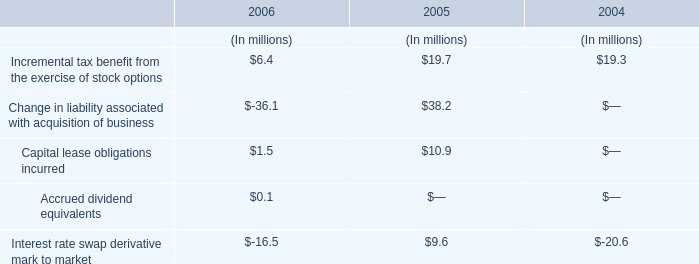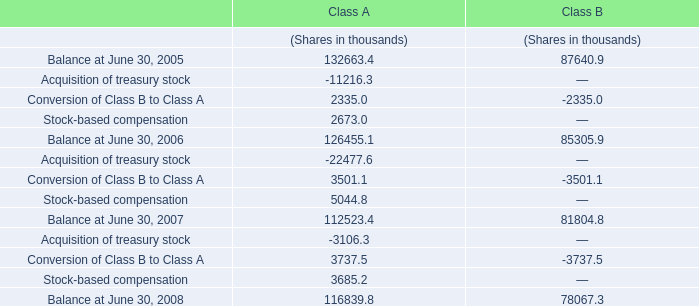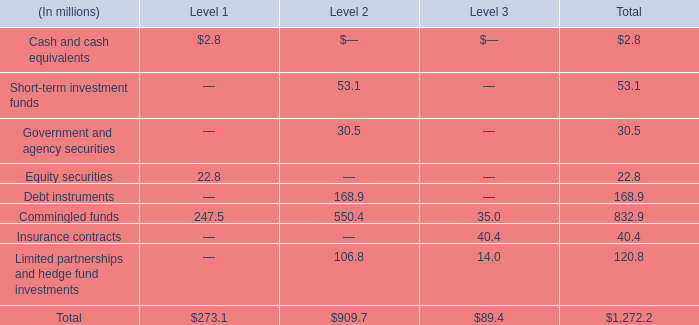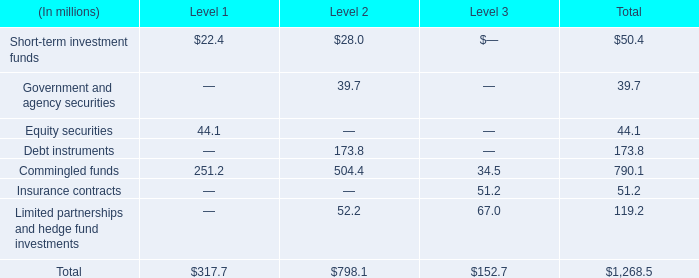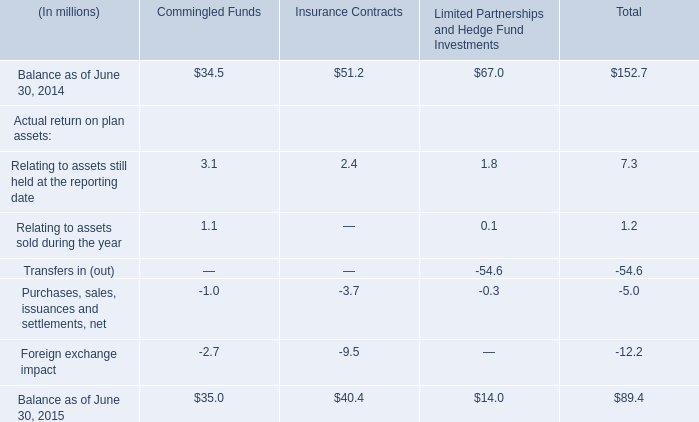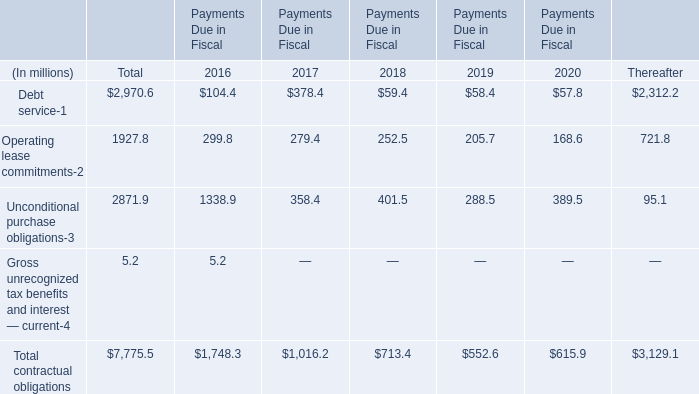What was the average of Commingled funds for Level 1, Level 2, and Level 3 ? (in million) 
Computations: (((247.5 + 550.4) + 35.0) / 3)
Answer: 277.63333. 